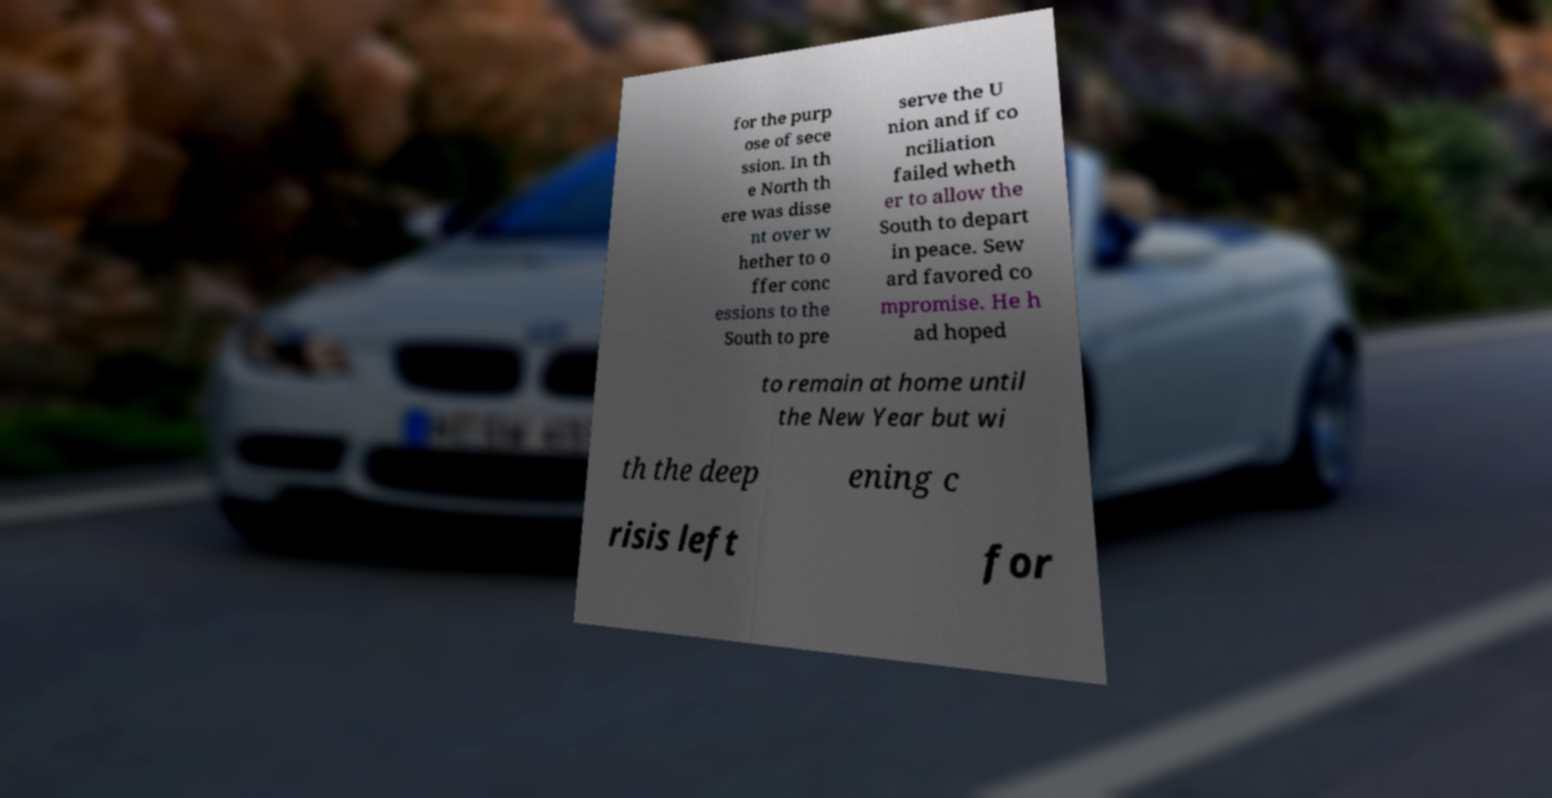Can you read and provide the text displayed in the image?This photo seems to have some interesting text. Can you extract and type it out for me? for the purp ose of sece ssion. In th e North th ere was disse nt over w hether to o ffer conc essions to the South to pre serve the U nion and if co nciliation failed wheth er to allow the South to depart in peace. Sew ard favored co mpromise. He h ad hoped to remain at home until the New Year but wi th the deep ening c risis left for 